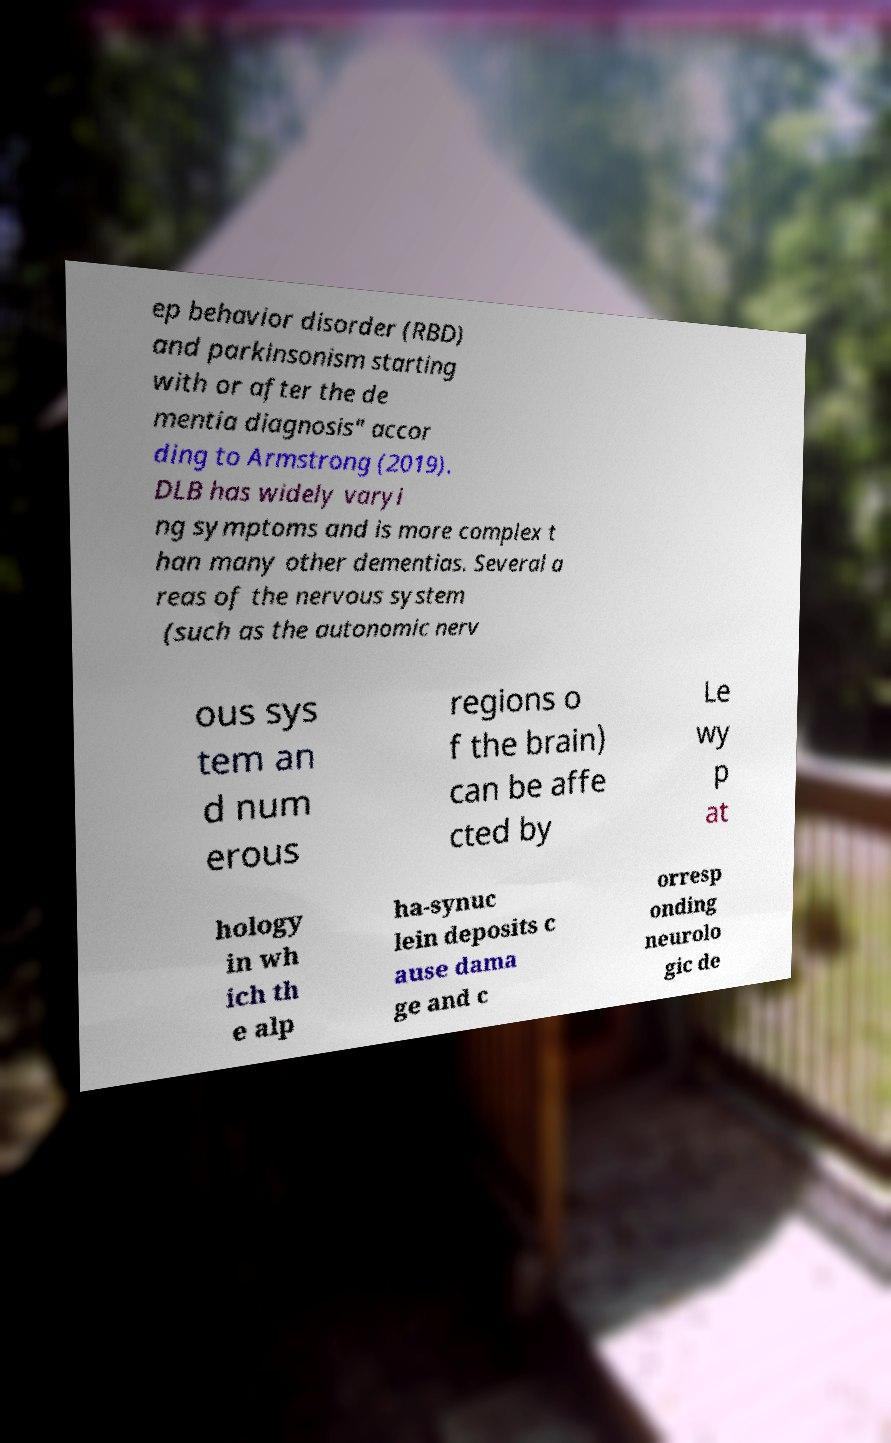Could you assist in decoding the text presented in this image and type it out clearly? ep behavior disorder (RBD) and parkinsonism starting with or after the de mentia diagnosis" accor ding to Armstrong (2019). DLB has widely varyi ng symptoms and is more complex t han many other dementias. Several a reas of the nervous system (such as the autonomic nerv ous sys tem an d num erous regions o f the brain) can be affe cted by Le wy p at hology in wh ich th e alp ha-synuc lein deposits c ause dama ge and c orresp onding neurolo gic de 